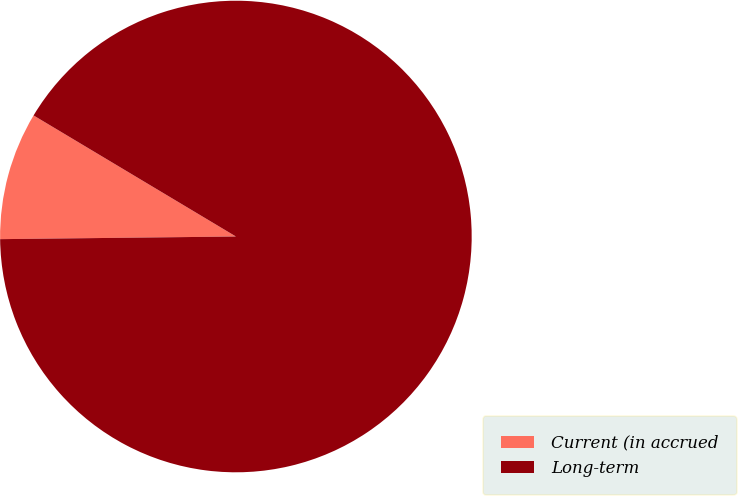Convert chart to OTSL. <chart><loc_0><loc_0><loc_500><loc_500><pie_chart><fcel>Current (in accrued<fcel>Long-term<nl><fcel>8.76%<fcel>91.24%<nl></chart> 